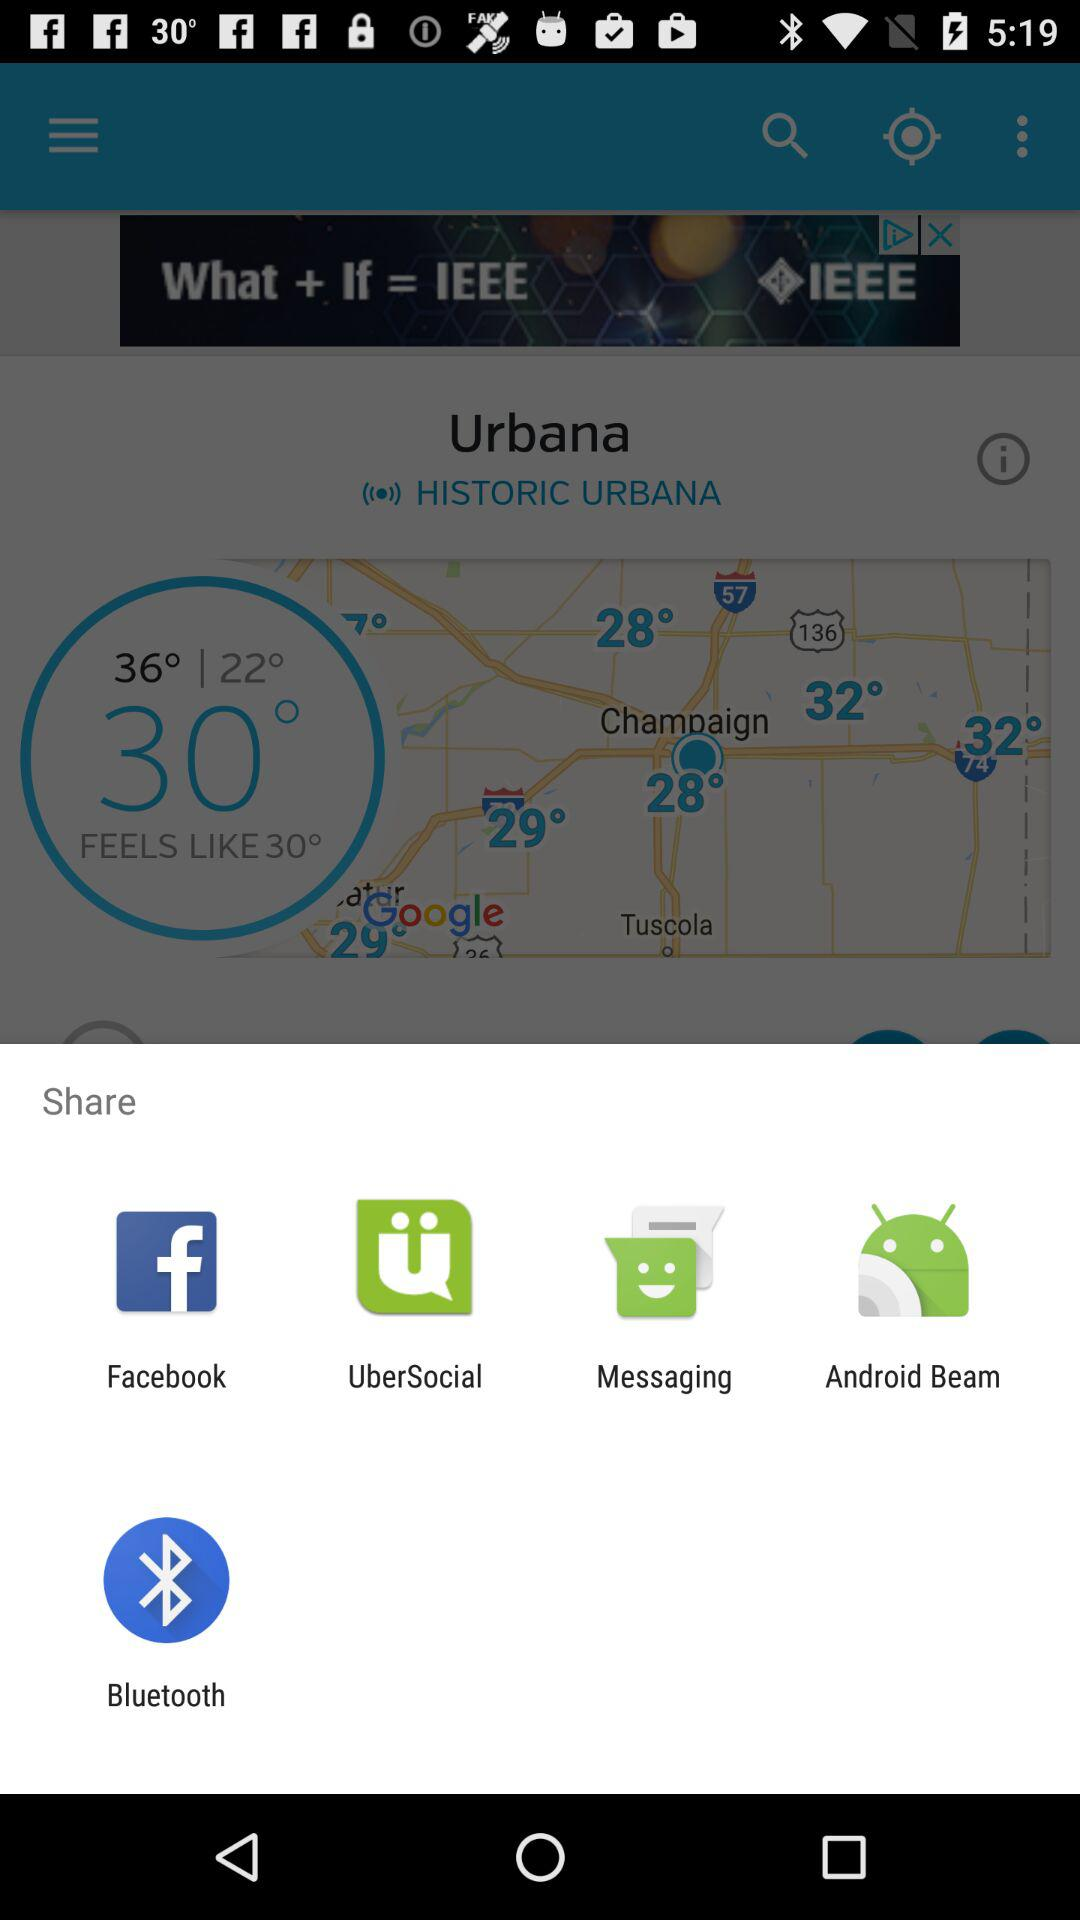Will it be warmer tomorrow?
When the provided information is insufficient, respond with <no answer>. <no answer> 